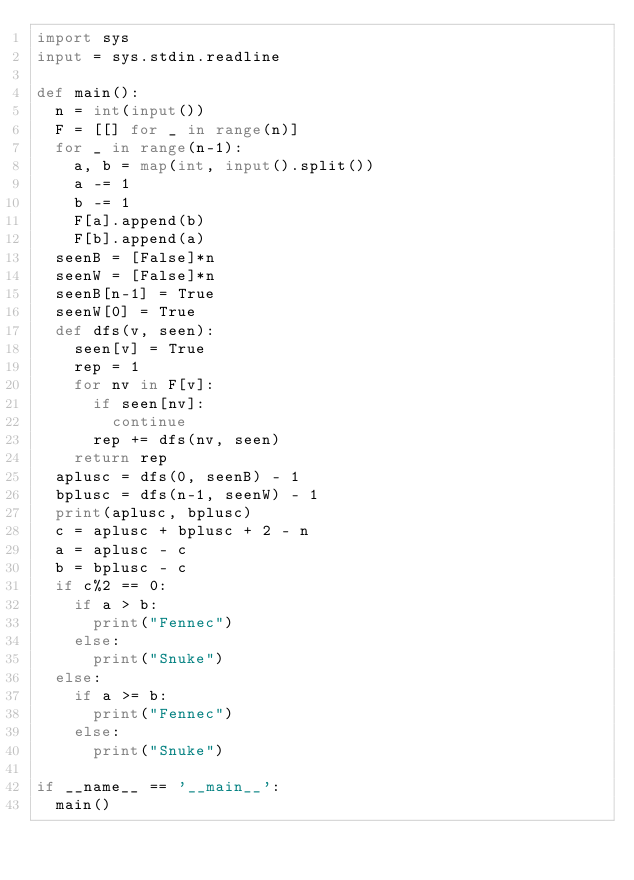<code> <loc_0><loc_0><loc_500><loc_500><_Python_>import sys
input = sys.stdin.readline

def main():
  n = int(input())
  F = [[] for _ in range(n)]
  for _ in range(n-1):
    a, b = map(int, input().split())
    a -= 1
    b -= 1
    F[a].append(b)
    F[b].append(a)
  seenB = [False]*n
  seenW = [False]*n
  seenB[n-1] = True
  seenW[0] = True
  def dfs(v, seen):
    seen[v] = True
    rep = 1
    for nv in F[v]:
      if seen[nv]:
        continue
      rep += dfs(nv, seen)
    return rep
  aplusc = dfs(0, seenB) - 1
  bplusc = dfs(n-1, seenW) - 1
  print(aplusc, bplusc)
  c = aplusc + bplusc + 2 - n
  a = aplusc - c
  b = bplusc - c
  if c%2 == 0:
    if a > b:
      print("Fennec")
    else:
      print("Snuke")
  else:
    if a >= b:
      print("Fennec")
    else:
      print("Snuke")
      
if __name__ == '__main__':
  main()</code> 